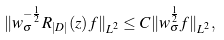Convert formula to latex. <formula><loc_0><loc_0><loc_500><loc_500>\| w _ { \sigma } ^ { - \frac { 1 } { 2 } } R _ { | D | } ( z ) f \| _ { L ^ { 2 } } \leq C \| w _ { \sigma } ^ { \frac { 1 } { 2 } } f \| _ { L ^ { 2 } } ,</formula> 